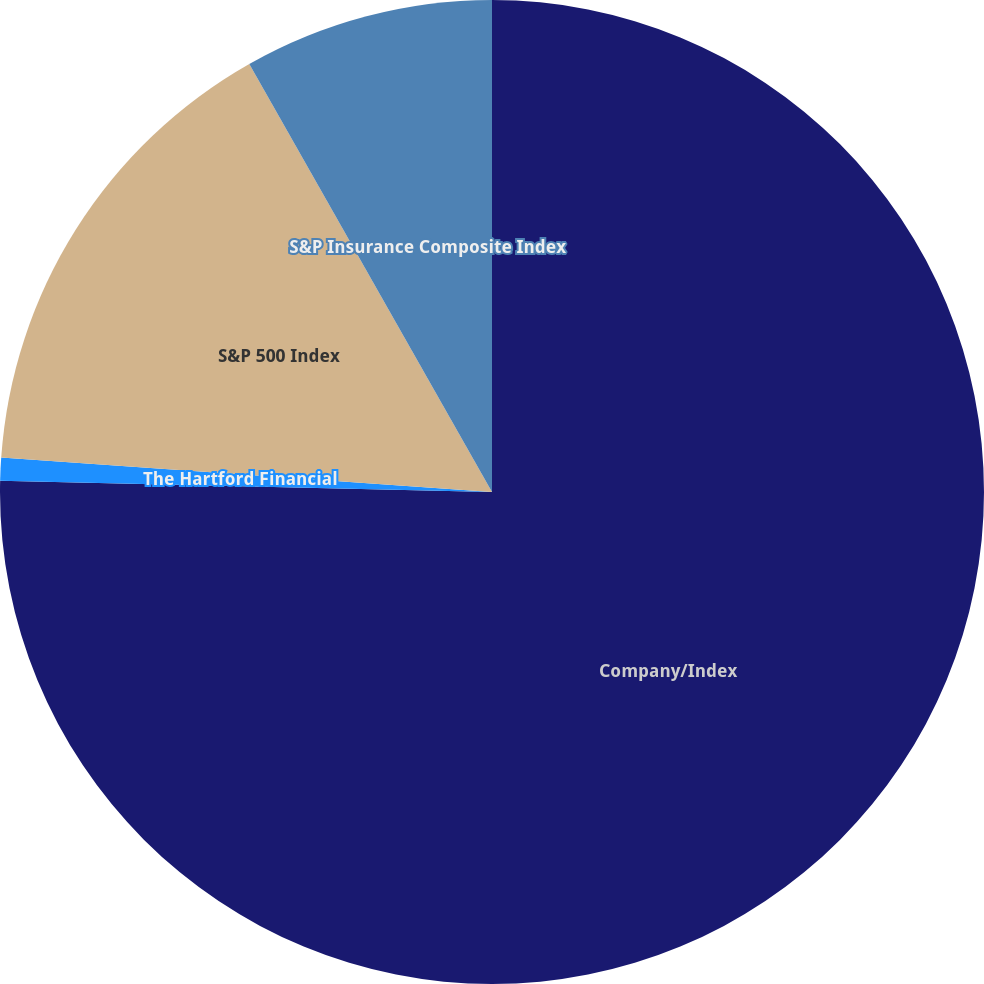<chart> <loc_0><loc_0><loc_500><loc_500><pie_chart><fcel>Company/Index<fcel>The Hartford Financial<fcel>S&P 500 Index<fcel>S&P Insurance Composite Index<nl><fcel>75.36%<fcel>0.75%<fcel>15.67%<fcel>8.21%<nl></chart> 